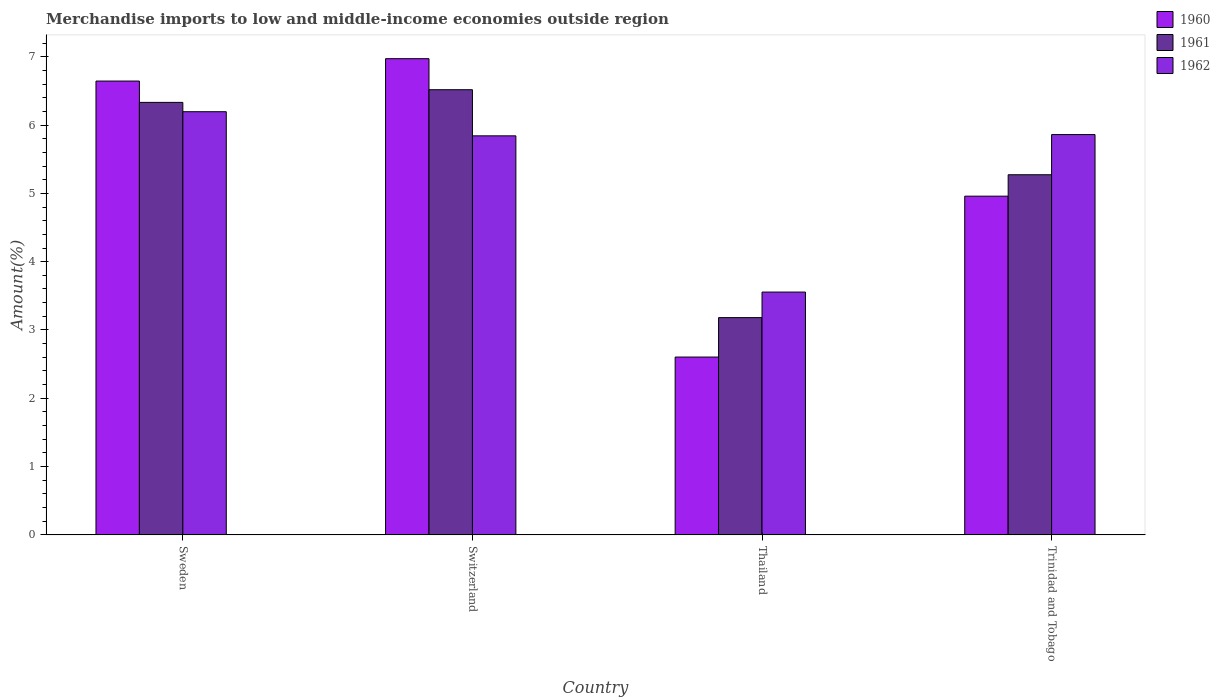How many different coloured bars are there?
Your answer should be very brief. 3. Are the number of bars per tick equal to the number of legend labels?
Your answer should be very brief. Yes. How many bars are there on the 3rd tick from the left?
Provide a succinct answer. 3. What is the label of the 2nd group of bars from the left?
Make the answer very short. Switzerland. What is the percentage of amount earned from merchandise imports in 1961 in Trinidad and Tobago?
Keep it short and to the point. 5.27. Across all countries, what is the maximum percentage of amount earned from merchandise imports in 1962?
Keep it short and to the point. 6.2. Across all countries, what is the minimum percentage of amount earned from merchandise imports in 1960?
Your answer should be very brief. 2.6. In which country was the percentage of amount earned from merchandise imports in 1961 maximum?
Make the answer very short. Switzerland. In which country was the percentage of amount earned from merchandise imports in 1960 minimum?
Your response must be concise. Thailand. What is the total percentage of amount earned from merchandise imports in 1962 in the graph?
Your answer should be very brief. 21.45. What is the difference between the percentage of amount earned from merchandise imports in 1961 in Sweden and that in Trinidad and Tobago?
Give a very brief answer. 1.06. What is the difference between the percentage of amount earned from merchandise imports in 1962 in Switzerland and the percentage of amount earned from merchandise imports in 1960 in Thailand?
Your answer should be compact. 3.24. What is the average percentage of amount earned from merchandise imports in 1962 per country?
Your answer should be compact. 5.36. What is the difference between the percentage of amount earned from merchandise imports of/in 1962 and percentage of amount earned from merchandise imports of/in 1961 in Sweden?
Ensure brevity in your answer.  -0.14. What is the ratio of the percentage of amount earned from merchandise imports in 1961 in Thailand to that in Trinidad and Tobago?
Offer a very short reply. 0.6. What is the difference between the highest and the second highest percentage of amount earned from merchandise imports in 1961?
Provide a succinct answer. -1.24. What is the difference between the highest and the lowest percentage of amount earned from merchandise imports in 1960?
Give a very brief answer. 4.37. What does the 1st bar from the right in Sweden represents?
Keep it short and to the point. 1962. Is it the case that in every country, the sum of the percentage of amount earned from merchandise imports in 1960 and percentage of amount earned from merchandise imports in 1962 is greater than the percentage of amount earned from merchandise imports in 1961?
Offer a terse response. Yes. Are all the bars in the graph horizontal?
Provide a short and direct response. No. Are the values on the major ticks of Y-axis written in scientific E-notation?
Your response must be concise. No. Does the graph contain any zero values?
Your answer should be very brief. No. Where does the legend appear in the graph?
Give a very brief answer. Top right. How are the legend labels stacked?
Provide a succinct answer. Vertical. What is the title of the graph?
Make the answer very short. Merchandise imports to low and middle-income economies outside region. Does "1995" appear as one of the legend labels in the graph?
Provide a succinct answer. No. What is the label or title of the X-axis?
Keep it short and to the point. Country. What is the label or title of the Y-axis?
Offer a very short reply. Amount(%). What is the Amount(%) of 1960 in Sweden?
Offer a terse response. 6.64. What is the Amount(%) of 1961 in Sweden?
Provide a short and direct response. 6.33. What is the Amount(%) of 1962 in Sweden?
Ensure brevity in your answer.  6.2. What is the Amount(%) in 1960 in Switzerland?
Offer a terse response. 6.97. What is the Amount(%) of 1961 in Switzerland?
Keep it short and to the point. 6.52. What is the Amount(%) of 1962 in Switzerland?
Offer a very short reply. 5.84. What is the Amount(%) in 1960 in Thailand?
Offer a terse response. 2.6. What is the Amount(%) of 1961 in Thailand?
Offer a very short reply. 3.18. What is the Amount(%) of 1962 in Thailand?
Make the answer very short. 3.55. What is the Amount(%) in 1960 in Trinidad and Tobago?
Make the answer very short. 4.96. What is the Amount(%) of 1961 in Trinidad and Tobago?
Give a very brief answer. 5.27. What is the Amount(%) in 1962 in Trinidad and Tobago?
Provide a succinct answer. 5.86. Across all countries, what is the maximum Amount(%) of 1960?
Your answer should be compact. 6.97. Across all countries, what is the maximum Amount(%) in 1961?
Your answer should be compact. 6.52. Across all countries, what is the maximum Amount(%) of 1962?
Offer a terse response. 6.2. Across all countries, what is the minimum Amount(%) in 1960?
Make the answer very short. 2.6. Across all countries, what is the minimum Amount(%) in 1961?
Give a very brief answer. 3.18. Across all countries, what is the minimum Amount(%) in 1962?
Keep it short and to the point. 3.55. What is the total Amount(%) of 1960 in the graph?
Keep it short and to the point. 21.18. What is the total Amount(%) in 1961 in the graph?
Your answer should be compact. 21.3. What is the total Amount(%) in 1962 in the graph?
Your answer should be compact. 21.45. What is the difference between the Amount(%) in 1960 in Sweden and that in Switzerland?
Offer a terse response. -0.33. What is the difference between the Amount(%) in 1961 in Sweden and that in Switzerland?
Your answer should be very brief. -0.19. What is the difference between the Amount(%) in 1962 in Sweden and that in Switzerland?
Keep it short and to the point. 0.35. What is the difference between the Amount(%) in 1960 in Sweden and that in Thailand?
Offer a very short reply. 4.04. What is the difference between the Amount(%) in 1961 in Sweden and that in Thailand?
Provide a short and direct response. 3.15. What is the difference between the Amount(%) of 1962 in Sweden and that in Thailand?
Ensure brevity in your answer.  2.64. What is the difference between the Amount(%) in 1960 in Sweden and that in Trinidad and Tobago?
Ensure brevity in your answer.  1.69. What is the difference between the Amount(%) in 1961 in Sweden and that in Trinidad and Tobago?
Ensure brevity in your answer.  1.06. What is the difference between the Amount(%) of 1962 in Sweden and that in Trinidad and Tobago?
Offer a very short reply. 0.33. What is the difference between the Amount(%) in 1960 in Switzerland and that in Thailand?
Offer a very short reply. 4.37. What is the difference between the Amount(%) in 1961 in Switzerland and that in Thailand?
Keep it short and to the point. 3.34. What is the difference between the Amount(%) in 1962 in Switzerland and that in Thailand?
Keep it short and to the point. 2.29. What is the difference between the Amount(%) of 1960 in Switzerland and that in Trinidad and Tobago?
Provide a succinct answer. 2.01. What is the difference between the Amount(%) of 1961 in Switzerland and that in Trinidad and Tobago?
Make the answer very short. 1.25. What is the difference between the Amount(%) in 1962 in Switzerland and that in Trinidad and Tobago?
Keep it short and to the point. -0.02. What is the difference between the Amount(%) in 1960 in Thailand and that in Trinidad and Tobago?
Provide a succinct answer. -2.36. What is the difference between the Amount(%) of 1961 in Thailand and that in Trinidad and Tobago?
Your response must be concise. -2.09. What is the difference between the Amount(%) in 1962 in Thailand and that in Trinidad and Tobago?
Your response must be concise. -2.31. What is the difference between the Amount(%) in 1960 in Sweden and the Amount(%) in 1961 in Switzerland?
Offer a terse response. 0.13. What is the difference between the Amount(%) of 1960 in Sweden and the Amount(%) of 1962 in Switzerland?
Make the answer very short. 0.8. What is the difference between the Amount(%) in 1961 in Sweden and the Amount(%) in 1962 in Switzerland?
Keep it short and to the point. 0.49. What is the difference between the Amount(%) of 1960 in Sweden and the Amount(%) of 1961 in Thailand?
Offer a very short reply. 3.46. What is the difference between the Amount(%) of 1960 in Sweden and the Amount(%) of 1962 in Thailand?
Your answer should be compact. 3.09. What is the difference between the Amount(%) of 1961 in Sweden and the Amount(%) of 1962 in Thailand?
Make the answer very short. 2.78. What is the difference between the Amount(%) in 1960 in Sweden and the Amount(%) in 1961 in Trinidad and Tobago?
Offer a very short reply. 1.37. What is the difference between the Amount(%) in 1960 in Sweden and the Amount(%) in 1962 in Trinidad and Tobago?
Your answer should be compact. 0.78. What is the difference between the Amount(%) of 1961 in Sweden and the Amount(%) of 1962 in Trinidad and Tobago?
Provide a succinct answer. 0.47. What is the difference between the Amount(%) in 1960 in Switzerland and the Amount(%) in 1961 in Thailand?
Your response must be concise. 3.79. What is the difference between the Amount(%) of 1960 in Switzerland and the Amount(%) of 1962 in Thailand?
Provide a short and direct response. 3.42. What is the difference between the Amount(%) in 1961 in Switzerland and the Amount(%) in 1962 in Thailand?
Provide a short and direct response. 2.96. What is the difference between the Amount(%) of 1960 in Switzerland and the Amount(%) of 1961 in Trinidad and Tobago?
Give a very brief answer. 1.7. What is the difference between the Amount(%) in 1960 in Switzerland and the Amount(%) in 1962 in Trinidad and Tobago?
Ensure brevity in your answer.  1.11. What is the difference between the Amount(%) of 1961 in Switzerland and the Amount(%) of 1962 in Trinidad and Tobago?
Keep it short and to the point. 0.66. What is the difference between the Amount(%) in 1960 in Thailand and the Amount(%) in 1961 in Trinidad and Tobago?
Provide a succinct answer. -2.67. What is the difference between the Amount(%) of 1960 in Thailand and the Amount(%) of 1962 in Trinidad and Tobago?
Offer a terse response. -3.26. What is the difference between the Amount(%) of 1961 in Thailand and the Amount(%) of 1962 in Trinidad and Tobago?
Provide a succinct answer. -2.68. What is the average Amount(%) of 1960 per country?
Offer a very short reply. 5.29. What is the average Amount(%) of 1961 per country?
Your answer should be compact. 5.33. What is the average Amount(%) of 1962 per country?
Your answer should be very brief. 5.36. What is the difference between the Amount(%) in 1960 and Amount(%) in 1961 in Sweden?
Make the answer very short. 0.31. What is the difference between the Amount(%) of 1960 and Amount(%) of 1962 in Sweden?
Your answer should be compact. 0.45. What is the difference between the Amount(%) in 1961 and Amount(%) in 1962 in Sweden?
Offer a terse response. 0.14. What is the difference between the Amount(%) in 1960 and Amount(%) in 1961 in Switzerland?
Your response must be concise. 0.45. What is the difference between the Amount(%) in 1960 and Amount(%) in 1962 in Switzerland?
Your answer should be compact. 1.13. What is the difference between the Amount(%) of 1961 and Amount(%) of 1962 in Switzerland?
Offer a very short reply. 0.68. What is the difference between the Amount(%) in 1960 and Amount(%) in 1961 in Thailand?
Give a very brief answer. -0.58. What is the difference between the Amount(%) in 1960 and Amount(%) in 1962 in Thailand?
Keep it short and to the point. -0.95. What is the difference between the Amount(%) in 1961 and Amount(%) in 1962 in Thailand?
Provide a succinct answer. -0.37. What is the difference between the Amount(%) in 1960 and Amount(%) in 1961 in Trinidad and Tobago?
Your answer should be compact. -0.31. What is the difference between the Amount(%) in 1960 and Amount(%) in 1962 in Trinidad and Tobago?
Ensure brevity in your answer.  -0.9. What is the difference between the Amount(%) in 1961 and Amount(%) in 1962 in Trinidad and Tobago?
Your answer should be compact. -0.59. What is the ratio of the Amount(%) in 1960 in Sweden to that in Switzerland?
Ensure brevity in your answer.  0.95. What is the ratio of the Amount(%) in 1961 in Sweden to that in Switzerland?
Keep it short and to the point. 0.97. What is the ratio of the Amount(%) of 1962 in Sweden to that in Switzerland?
Keep it short and to the point. 1.06. What is the ratio of the Amount(%) in 1960 in Sweden to that in Thailand?
Make the answer very short. 2.55. What is the ratio of the Amount(%) of 1961 in Sweden to that in Thailand?
Offer a very short reply. 1.99. What is the ratio of the Amount(%) of 1962 in Sweden to that in Thailand?
Keep it short and to the point. 1.74. What is the ratio of the Amount(%) of 1960 in Sweden to that in Trinidad and Tobago?
Offer a very short reply. 1.34. What is the ratio of the Amount(%) in 1961 in Sweden to that in Trinidad and Tobago?
Provide a succinct answer. 1.2. What is the ratio of the Amount(%) in 1962 in Sweden to that in Trinidad and Tobago?
Provide a succinct answer. 1.06. What is the ratio of the Amount(%) of 1960 in Switzerland to that in Thailand?
Offer a terse response. 2.68. What is the ratio of the Amount(%) of 1961 in Switzerland to that in Thailand?
Your answer should be very brief. 2.05. What is the ratio of the Amount(%) of 1962 in Switzerland to that in Thailand?
Keep it short and to the point. 1.64. What is the ratio of the Amount(%) of 1960 in Switzerland to that in Trinidad and Tobago?
Your response must be concise. 1.41. What is the ratio of the Amount(%) in 1961 in Switzerland to that in Trinidad and Tobago?
Your response must be concise. 1.24. What is the ratio of the Amount(%) of 1960 in Thailand to that in Trinidad and Tobago?
Make the answer very short. 0.53. What is the ratio of the Amount(%) of 1961 in Thailand to that in Trinidad and Tobago?
Your response must be concise. 0.6. What is the ratio of the Amount(%) in 1962 in Thailand to that in Trinidad and Tobago?
Give a very brief answer. 0.61. What is the difference between the highest and the second highest Amount(%) of 1960?
Keep it short and to the point. 0.33. What is the difference between the highest and the second highest Amount(%) of 1961?
Give a very brief answer. 0.19. What is the difference between the highest and the second highest Amount(%) of 1962?
Provide a succinct answer. 0.33. What is the difference between the highest and the lowest Amount(%) of 1960?
Provide a succinct answer. 4.37. What is the difference between the highest and the lowest Amount(%) of 1961?
Provide a short and direct response. 3.34. What is the difference between the highest and the lowest Amount(%) of 1962?
Your response must be concise. 2.64. 